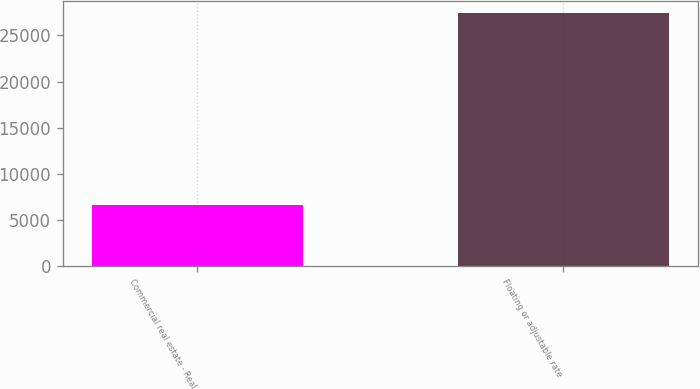Convert chart to OTSL. <chart><loc_0><loc_0><loc_500><loc_500><bar_chart><fcel>Commercial real estate - Real<fcel>Floating or adjustable rate<nl><fcel>6613<fcel>27404<nl></chart> 